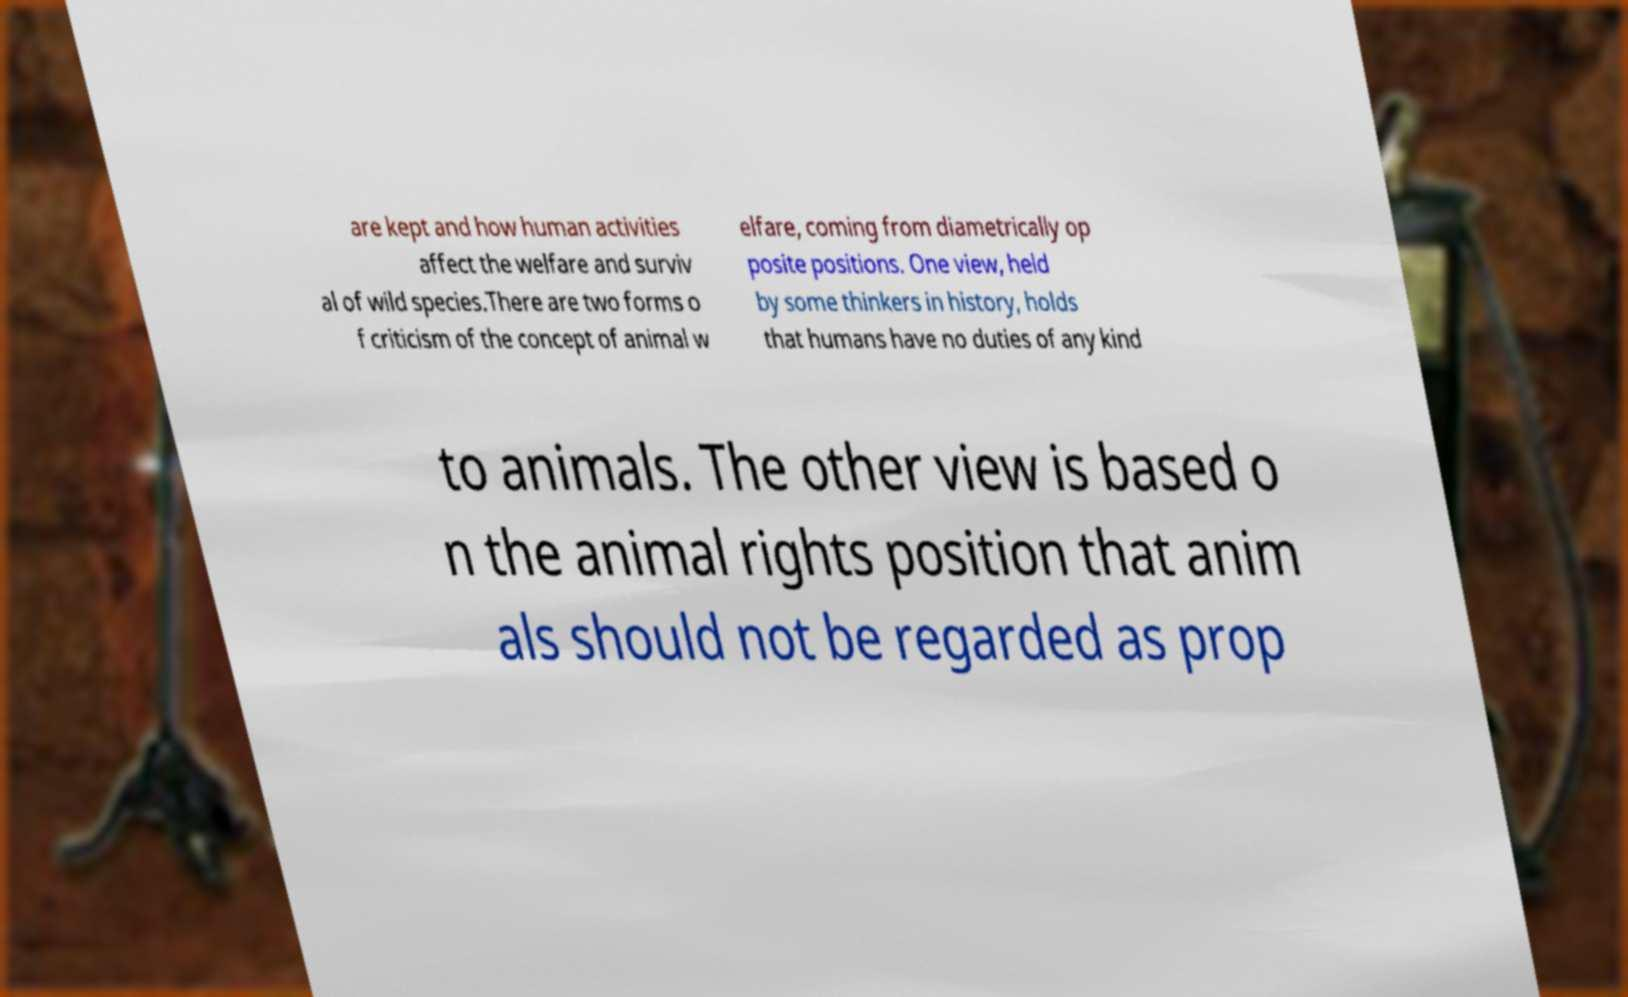Can you accurately transcribe the text from the provided image for me? are kept and how human activities affect the welfare and surviv al of wild species.There are two forms o f criticism of the concept of animal w elfare, coming from diametrically op posite positions. One view, held by some thinkers in history, holds that humans have no duties of any kind to animals. The other view is based o n the animal rights position that anim als should not be regarded as prop 